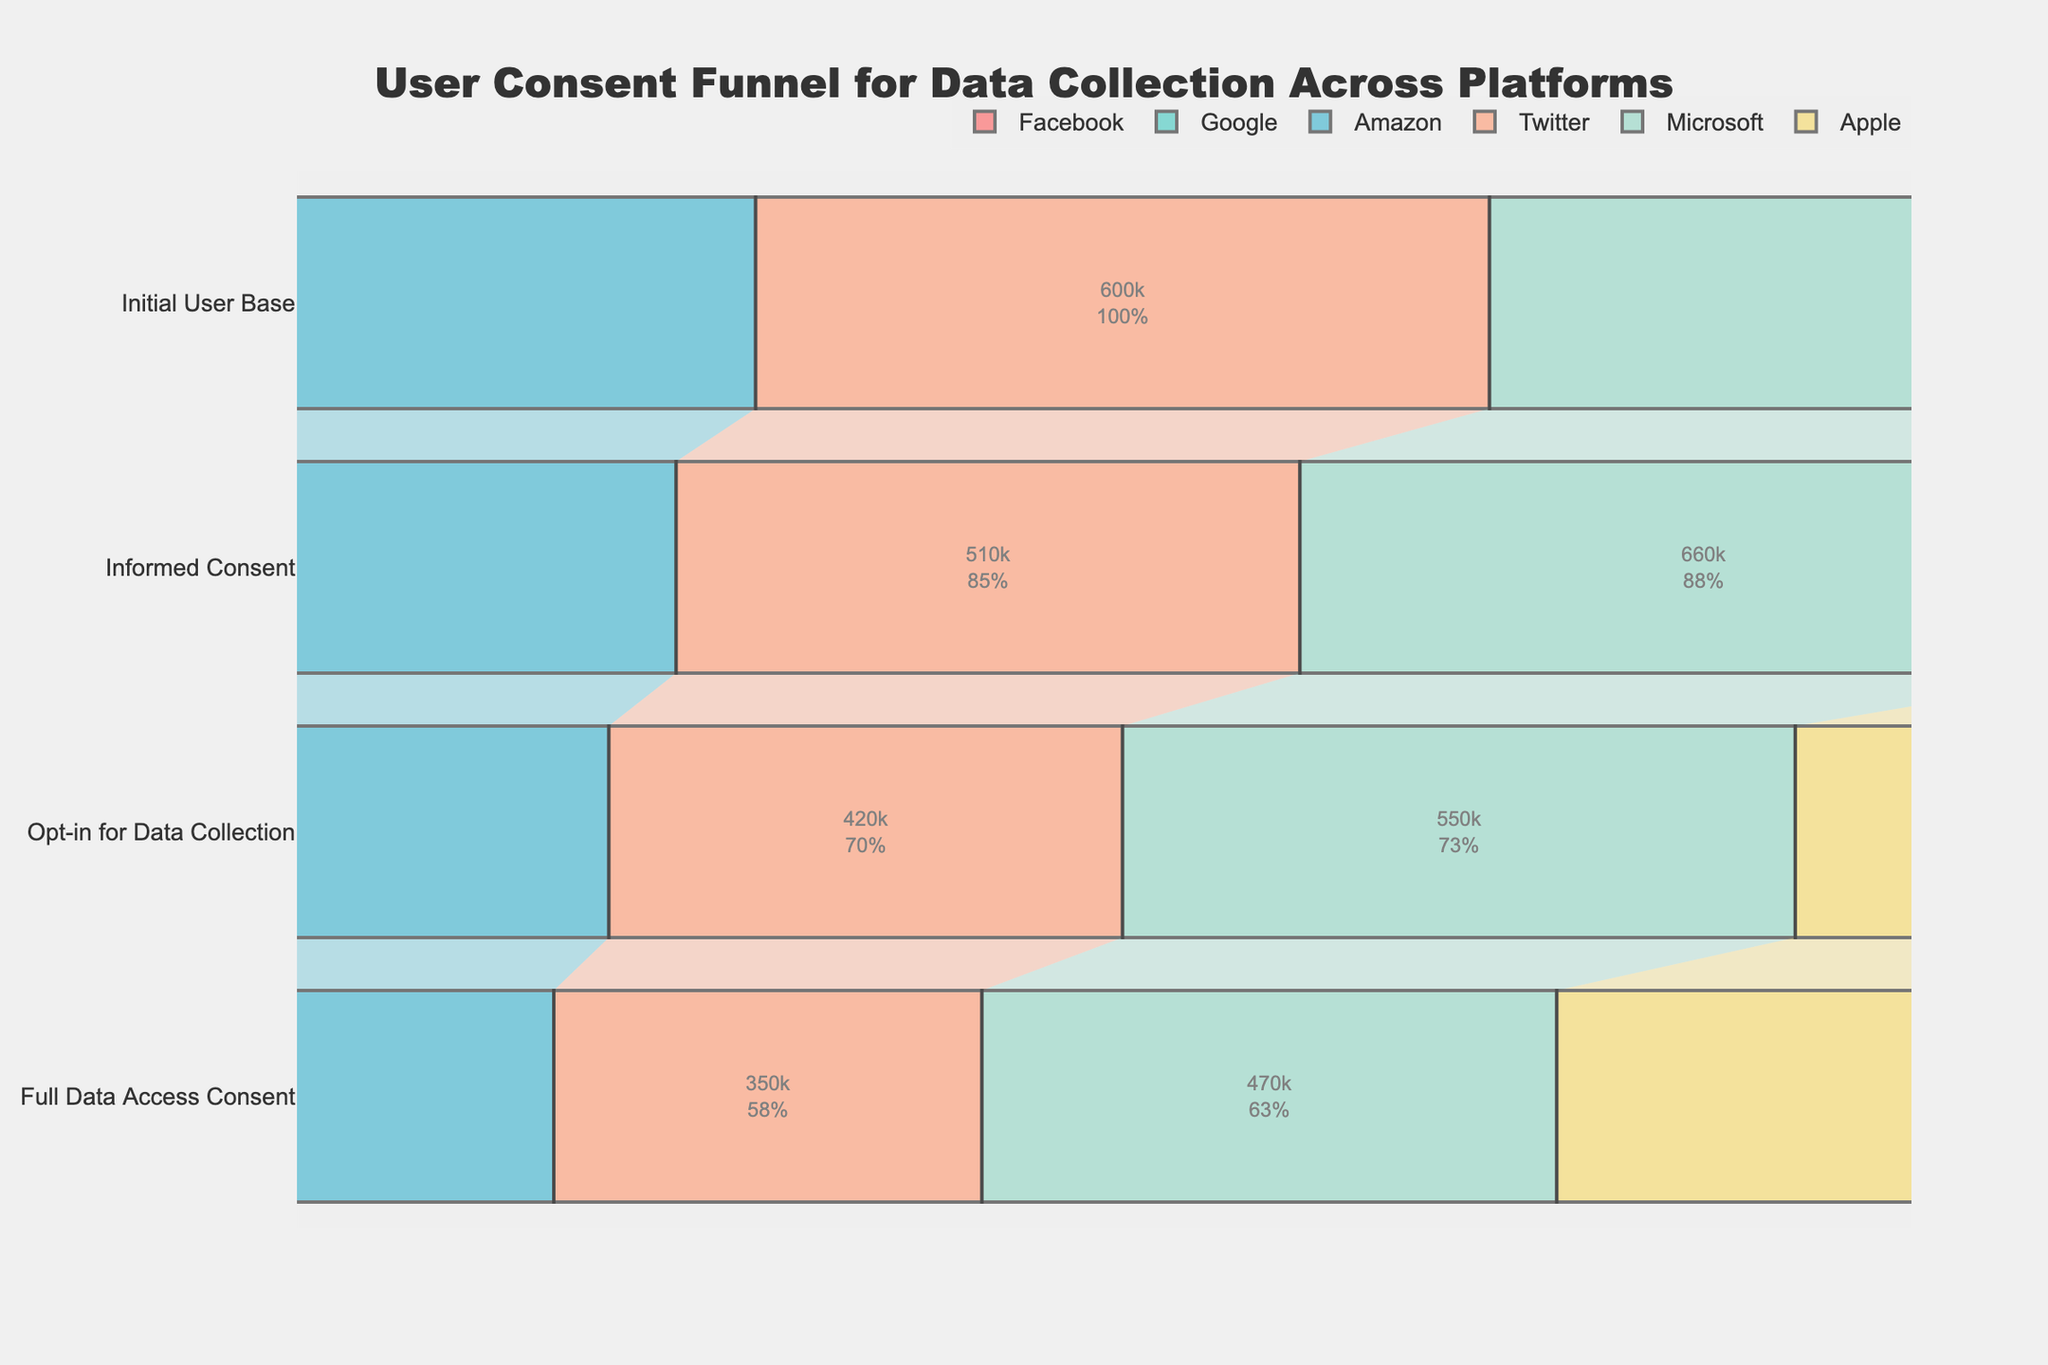What's the initial user base for Amazon? The initial user base for Amazon is indicated at the top of the funnel for Amazon.
Answer: 800000 Which platform has the highest number of fully consenting users? By comparing the numbers for full data access consent across all platforms, we see that Google has the highest number.
Answer: Google What is the sum of users who have opted in for data collection across Facebook and Twitter? Facebook has 720000, and Twitter has 420000 in the 'Opt-in for Data Collection' stage. Summing these two values gives 1140000.
Answer: 1140000 Among Apple, Google, and Microsoft, which platform has the lowest informed consent rate? Comparing the 'Informed Consent' figures: Apple has 810000, Google has 1050000, and Microsoft has 660000, making Microsoft the lowest.
Answer: Microsoft What's the proportion of fully consenting users to the initial user base for Google? Fully consenting users for Google are 780000, and the initial user base is 1200000. The proportion is 780000/1200000 which simplifies to 0.65 or 65%.
Answer: 65% How many platforms have fewer than 500000 users who have fully consented? By checking the 'Full Data Access Consent' numbers, Amazon (480000) and Twitter (350000) have fewer than 500000 users. So, the number is two platforms.
Answer: 2 What is the difference in fully consenting users between Facebook and Microsoft? Facebook has 620000 fully consenting users, and Microsoft has 470000. The difference is 620000 - 470000 = 150000.
Answer: 150000 Which stage has the largest drop-off in users across all platforms? By examining each stage's user count decrement, one can calculate and determine that moving from 'Informed Consent' to 'Opt-in for Data Collection' tends to have the largest drop-off across most platforms.
Answer: Opt-in for Data Collection Compare the percentage of informed consent out of the initial user base for Amazon and Twitter. Which is higher? Calculating the ratio, for Amazon it's 700000/800000 = 0.875 or 87.5%, for Twitter it's 510000/600000 = 0.85 or 85%. Amazon has a higher percentage.
Answer: Amazon 